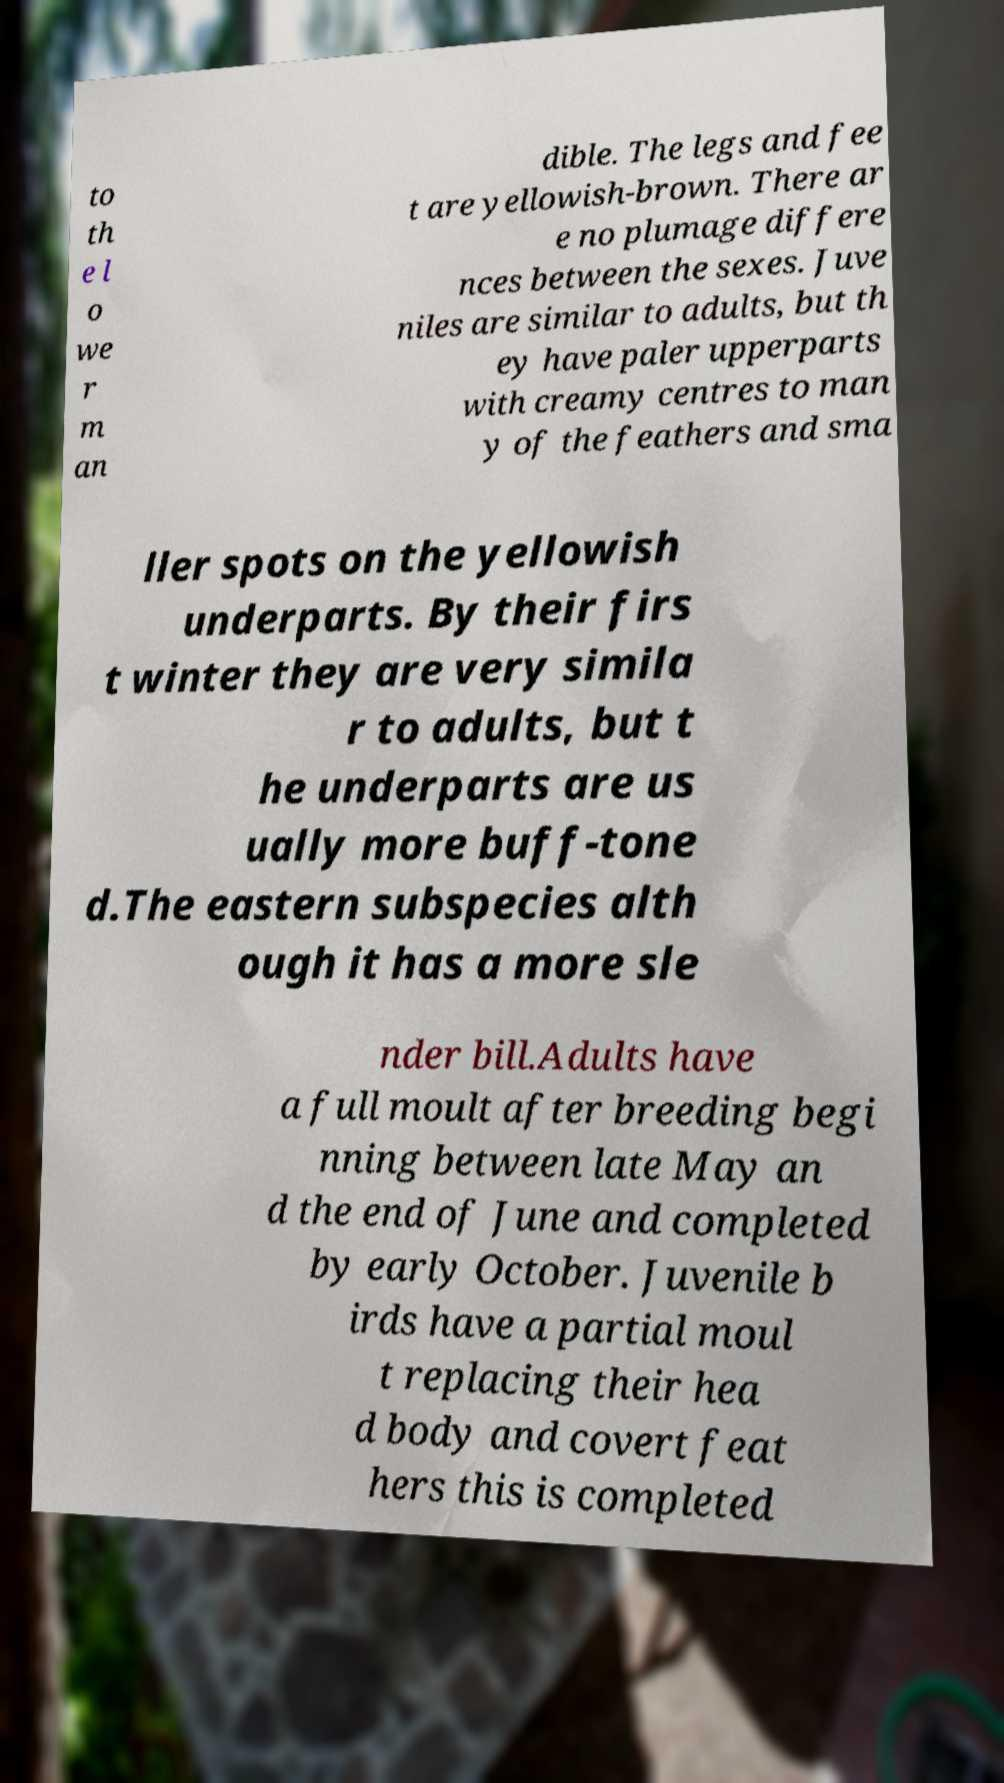Could you extract and type out the text from this image? to th e l o we r m an dible. The legs and fee t are yellowish-brown. There ar e no plumage differe nces between the sexes. Juve niles are similar to adults, but th ey have paler upperparts with creamy centres to man y of the feathers and sma ller spots on the yellowish underparts. By their firs t winter they are very simila r to adults, but t he underparts are us ually more buff-tone d.The eastern subspecies alth ough it has a more sle nder bill.Adults have a full moult after breeding begi nning between late May an d the end of June and completed by early October. Juvenile b irds have a partial moul t replacing their hea d body and covert feat hers this is completed 